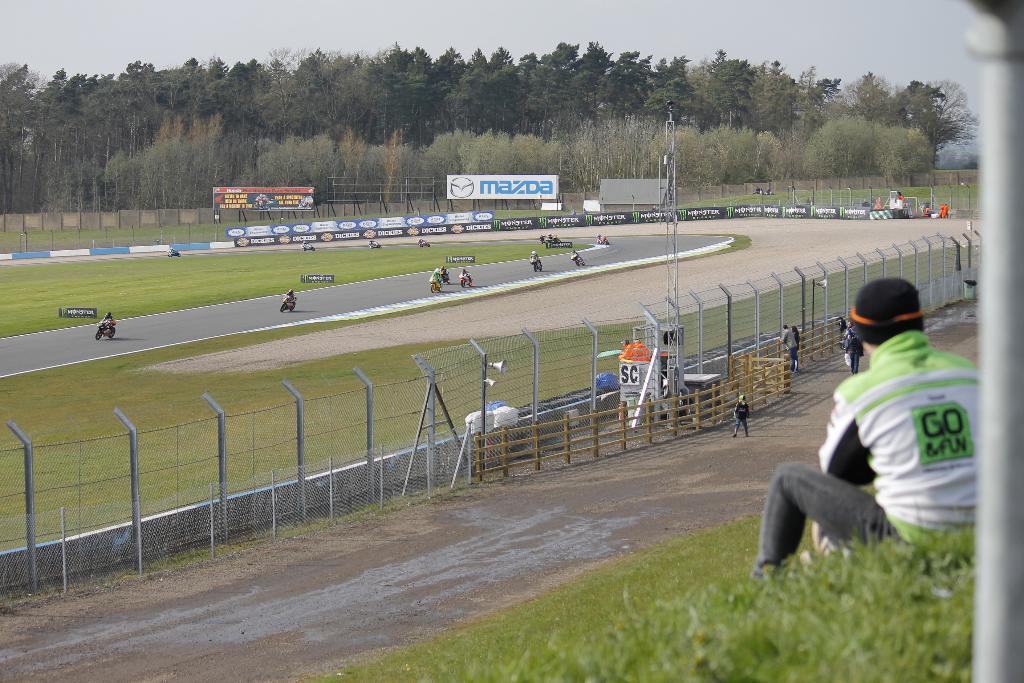Describe this image in one or two sentences. In this picture I can see a person sitting on the grass, there are group of people standing, there are group of people riding bikes on the road, there are fences, boards, trees, and in the background there is sky. 